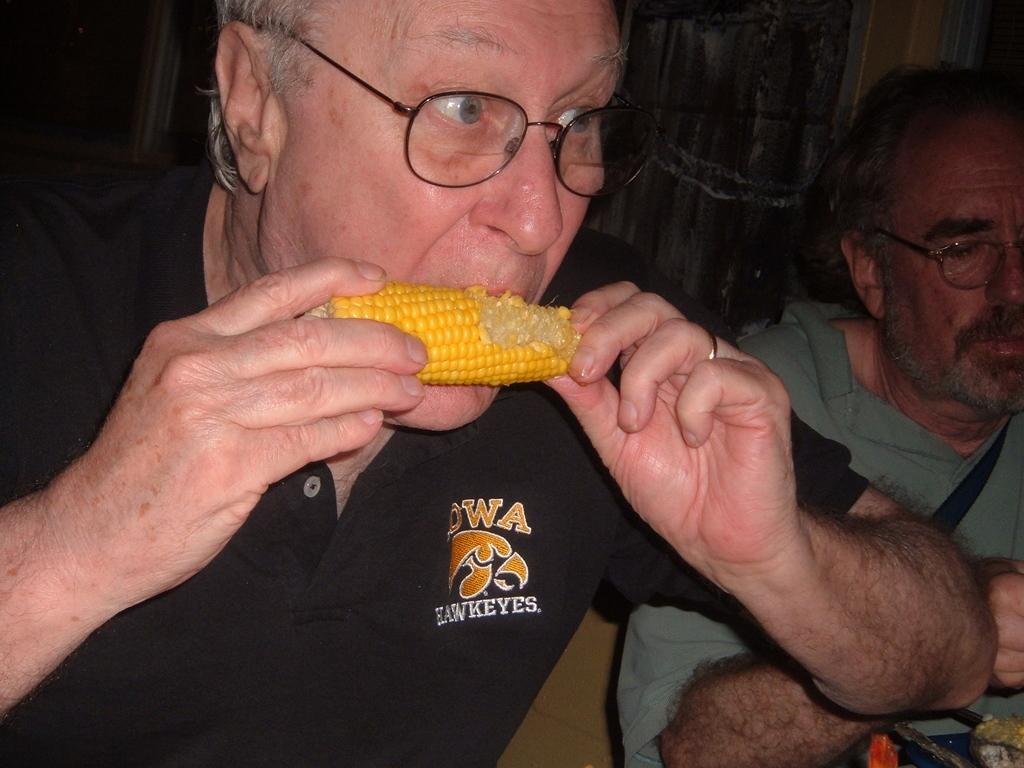How many people are in the image? There are two persons in the image. What is the man in the front wearing? The man in the front is wearing a black T-shirt. What is the man in the front doing? The man in the front is eating corn. What is the man on the right wearing? The man on the right is wearing a green T-shirt. What type of force is being applied to the sheet by the brass object? There is no sheet or brass object present in the image. 